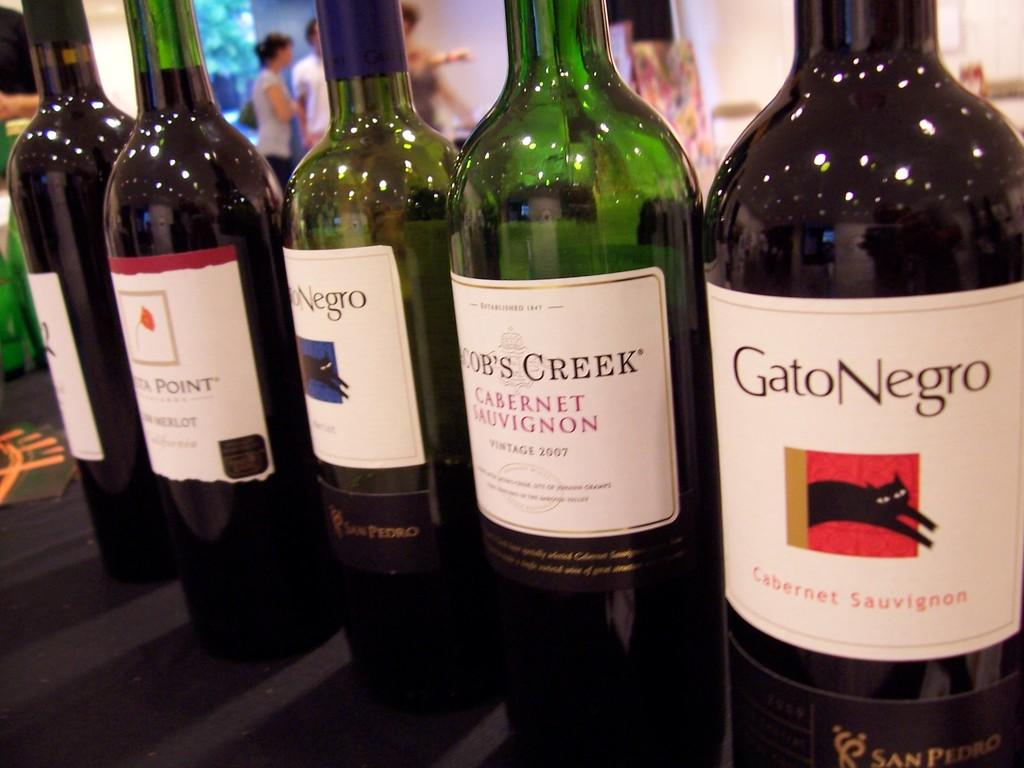<image>
Present a compact description of the photo's key features. Bottles of wine are lined up, including a cabernet by Gato Negro. 